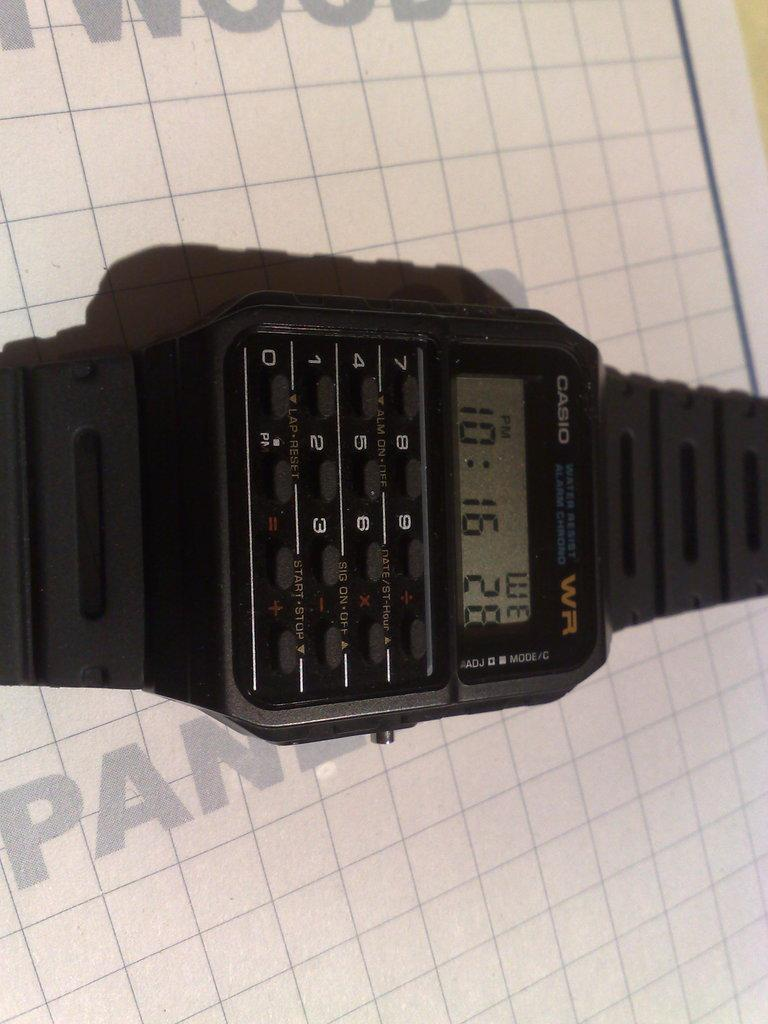<image>
Create a compact narrative representing the image presented. an old casio calculator watch is laying on a table 